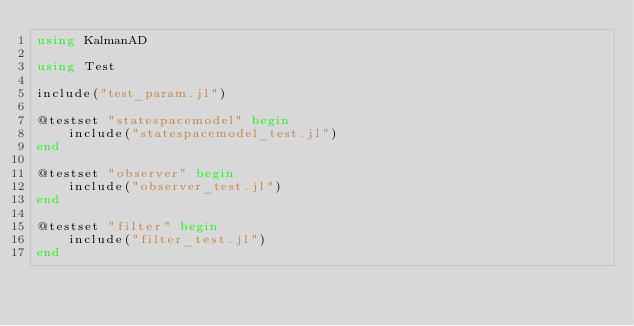Convert code to text. <code><loc_0><loc_0><loc_500><loc_500><_Julia_>using KalmanAD

using Test

include("test_param.jl")

@testset "statespacemodel" begin
    include("statespacemodel_test.jl")
end

@testset "observer" begin
    include("observer_test.jl")
end

@testset "filter" begin
    include("filter_test.jl")
end
</code> 